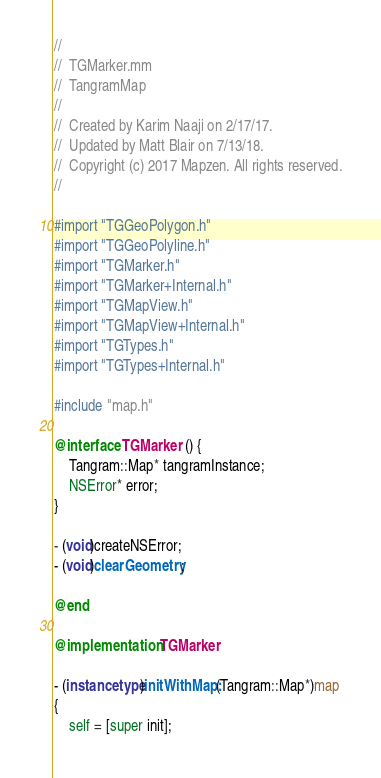Convert code to text. <code><loc_0><loc_0><loc_500><loc_500><_ObjectiveC_>//
//  TGMarker.mm
//  TangramMap
//
//  Created by Karim Naaji on 2/17/17.
//  Updated by Matt Blair on 7/13/18.
//  Copyright (c) 2017 Mapzen. All rights reserved.
//

#import "TGGeoPolygon.h"
#import "TGGeoPolyline.h"
#import "TGMarker.h"
#import "TGMarker+Internal.h"
#import "TGMapView.h"
#import "TGMapView+Internal.h"
#import "TGTypes.h"
#import "TGTypes+Internal.h"

#include "map.h"

@interface TGMarker () {
    Tangram::Map* tangramInstance;
    NSError* error;
}

- (void)createNSError;
- (void)clearGeometry;

@end

@implementation TGMarker

- (instancetype)initWithMap:(Tangram::Map*)map
{
    self = [super init];
</code> 